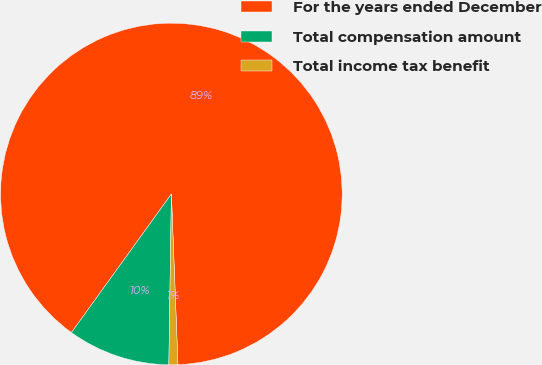Convert chart. <chart><loc_0><loc_0><loc_500><loc_500><pie_chart><fcel>For the years ended December<fcel>Total compensation amount<fcel>Total income tax benefit<nl><fcel>89.44%<fcel>9.71%<fcel>0.85%<nl></chart> 